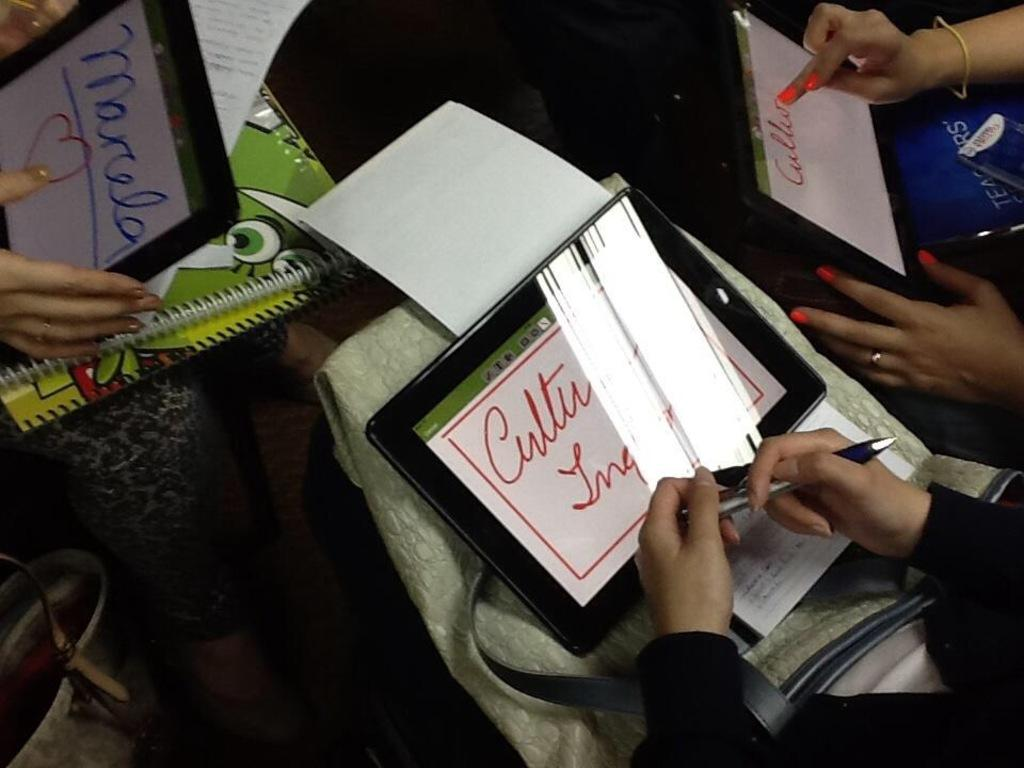What type of objects can be seen in the image? There are books, electronic gadgets, and backpacks in the image. What might be used for carrying or storing items in the image? The backpacks in the image can be used for carrying or storing items. Can you describe the person's hands in the image? A person's hands are visible in the image, but their actions or what they are holding cannot be determined from the provided facts. Where is the faucet located in the image? There is no faucet present in the image. What type of jump is the person performing in the image? There is no person jumping in the image; only their hands are visible. 